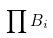<formula> <loc_0><loc_0><loc_500><loc_500>\prod B _ { i }</formula> 